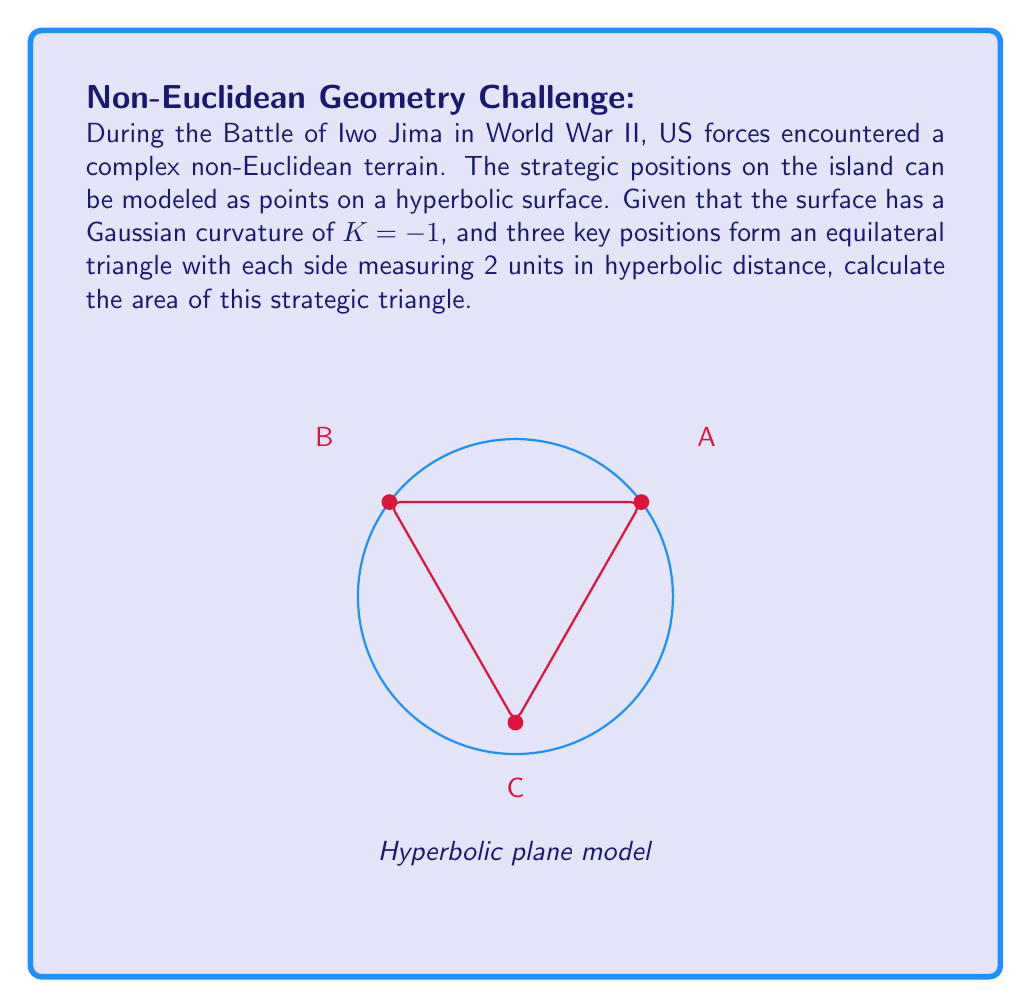Could you help me with this problem? To solve this problem, we'll use the formula for the area of a triangle in hyperbolic geometry. The steps are as follows:

1) In hyperbolic geometry, the area $A$ of a triangle is given by:

   $$A = \pi - (\alpha + \beta + \gamma)$$

   where $\alpha$, $\beta$, and $\gamma$ are the angles of the triangle.

2) For an equilateral triangle in hyperbolic geometry, all angles are equal. Let's call this angle $\theta$. So:

   $$A = \pi - 3\theta$$

3) To find $\theta$, we can use the hyperbolic law of cosines:

   $$\cosh(a) = \frac{\cos(\theta)}{\sin^2(\theta)}$$

   where $a$ is the length of a side.

4) We're given that $a = 2$ and $K = -1$. In hyperbolic geometry with $K = -1$, the hyperbolic functions are the same as the standard hyperbolic functions. So:

   $$\cosh(2) = \frac{\cos(\theta)}{\sin^2(\theta)}$$

5) Solving this equation:

   $$3.7622 = \frac{\cos(\theta)}{\sin^2(\theta)}$$
   $$3.7622\sin^2(\theta) = \cos(\theta)$$
   $$3.7622(1-\cos^2(\theta)) = \cos(\theta)$$
   $$3.7622 - 3.7622\cos^2(\theta) = \cos(\theta)$$
   $$3.7622\cos^2(\theta) + \cos(\theta) - 3.7622 = 0$$

6) This is a quadratic in $\cos(\theta)$. Solving it:

   $$\cos(\theta) \approx 0.8285$$
   $$\theta \approx 0.5969$$

7) Now we can calculate the area:

   $$A = \pi - 3(0.5969) \approx 1.3508$$

Thus, the area of the strategic triangle is approximately 1.3508 square units in the hyperbolic plane.
Answer: $1.3508$ square units 